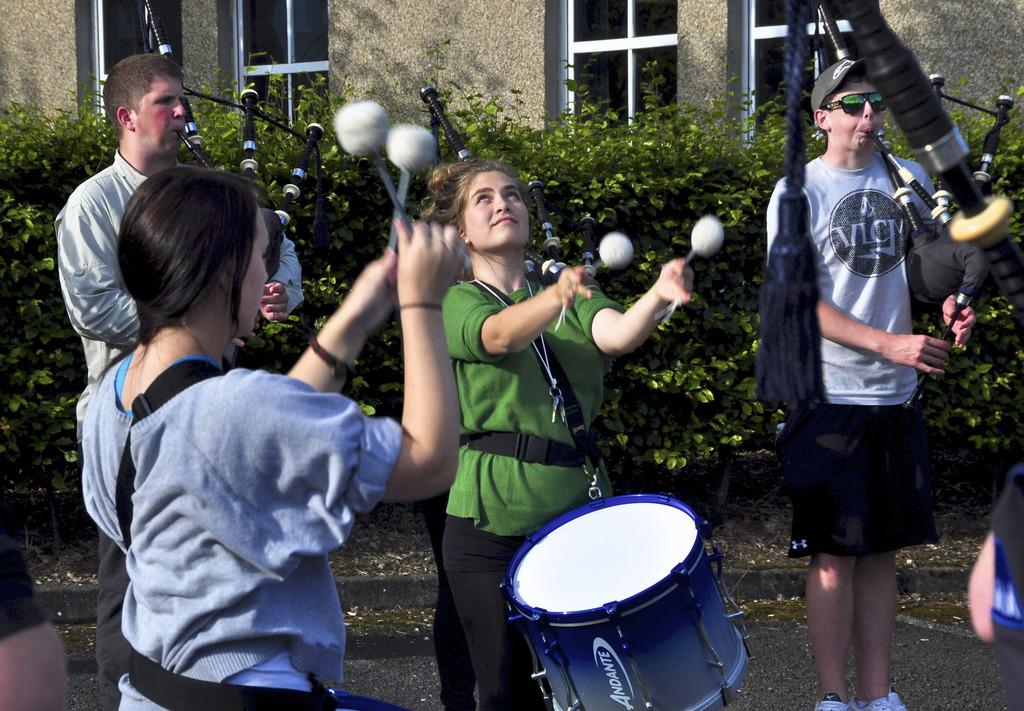What are the people in the image doing? The people in the image are playing musical instruments. What can be seen near the people? There are plants near the people. What type of structure is located near the people? There is a building near the people. What type of dock can be seen near the people in the image? There is no dock present in the image; it features people playing musical instruments with plants and a building nearby. 